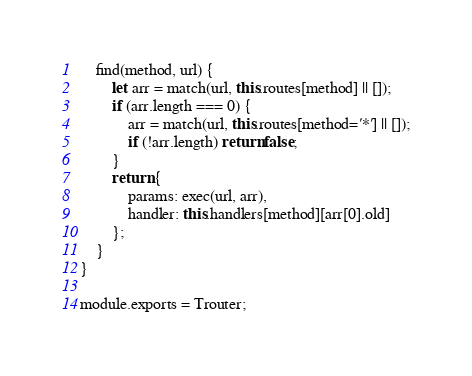Convert code to text. <code><loc_0><loc_0><loc_500><loc_500><_JavaScript_>	find(method, url) {
		let arr = match(url, this.routes[method] || []);
		if (arr.length === 0) {
			arr = match(url, this.routes[method='*'] || []);
			if (!arr.length) return false;
		}
		return {
			params: exec(url, arr),
			handler: this.handlers[method][arr[0].old]
		};
	}
}

module.exports = Trouter;
</code> 